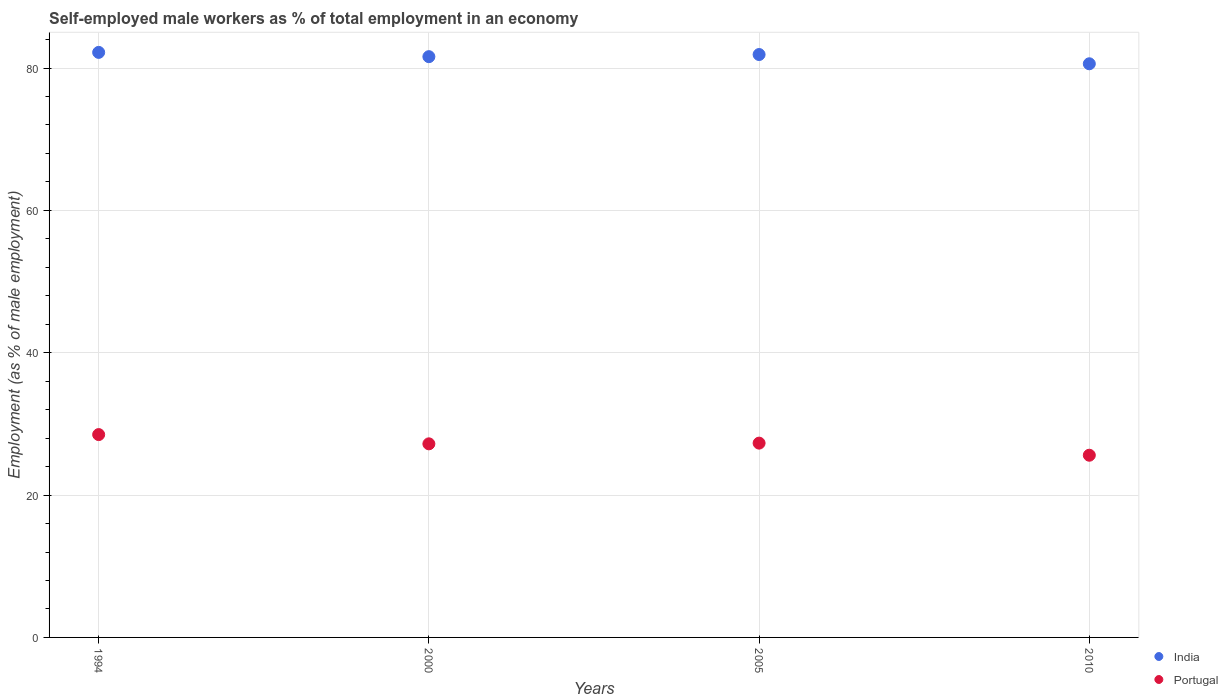What is the percentage of self-employed male workers in Portugal in 2005?
Keep it short and to the point. 27.3. Across all years, what is the maximum percentage of self-employed male workers in India?
Keep it short and to the point. 82.2. Across all years, what is the minimum percentage of self-employed male workers in India?
Ensure brevity in your answer.  80.6. In which year was the percentage of self-employed male workers in India maximum?
Provide a short and direct response. 1994. In which year was the percentage of self-employed male workers in Portugal minimum?
Your answer should be very brief. 2010. What is the total percentage of self-employed male workers in India in the graph?
Your answer should be very brief. 326.3. What is the difference between the percentage of self-employed male workers in Portugal in 2000 and that in 2010?
Provide a succinct answer. 1.6. What is the difference between the percentage of self-employed male workers in India in 1994 and the percentage of self-employed male workers in Portugal in 2010?
Your response must be concise. 56.6. What is the average percentage of self-employed male workers in Portugal per year?
Provide a succinct answer. 27.15. In the year 1994, what is the difference between the percentage of self-employed male workers in Portugal and percentage of self-employed male workers in India?
Offer a terse response. -53.7. In how many years, is the percentage of self-employed male workers in India greater than 52 %?
Offer a terse response. 4. What is the ratio of the percentage of self-employed male workers in India in 1994 to that in 2010?
Ensure brevity in your answer.  1.02. Is the percentage of self-employed male workers in India in 2000 less than that in 2010?
Provide a succinct answer. No. What is the difference between the highest and the second highest percentage of self-employed male workers in Portugal?
Provide a short and direct response. 1.2. What is the difference between the highest and the lowest percentage of self-employed male workers in India?
Your response must be concise. 1.6. Is the percentage of self-employed male workers in India strictly less than the percentage of self-employed male workers in Portugal over the years?
Offer a terse response. No. How many dotlines are there?
Your answer should be compact. 2. What is the difference between two consecutive major ticks on the Y-axis?
Give a very brief answer. 20. Does the graph contain any zero values?
Your answer should be compact. No. Does the graph contain grids?
Keep it short and to the point. Yes. Where does the legend appear in the graph?
Provide a short and direct response. Bottom right. What is the title of the graph?
Ensure brevity in your answer.  Self-employed male workers as % of total employment in an economy. What is the label or title of the X-axis?
Ensure brevity in your answer.  Years. What is the label or title of the Y-axis?
Make the answer very short. Employment (as % of male employment). What is the Employment (as % of male employment) of India in 1994?
Give a very brief answer. 82.2. What is the Employment (as % of male employment) of India in 2000?
Ensure brevity in your answer.  81.6. What is the Employment (as % of male employment) of Portugal in 2000?
Ensure brevity in your answer.  27.2. What is the Employment (as % of male employment) in India in 2005?
Provide a short and direct response. 81.9. What is the Employment (as % of male employment) of Portugal in 2005?
Provide a short and direct response. 27.3. What is the Employment (as % of male employment) of India in 2010?
Make the answer very short. 80.6. What is the Employment (as % of male employment) of Portugal in 2010?
Offer a terse response. 25.6. Across all years, what is the maximum Employment (as % of male employment) in India?
Make the answer very short. 82.2. Across all years, what is the maximum Employment (as % of male employment) of Portugal?
Your answer should be very brief. 28.5. Across all years, what is the minimum Employment (as % of male employment) of India?
Make the answer very short. 80.6. Across all years, what is the minimum Employment (as % of male employment) in Portugal?
Your answer should be very brief. 25.6. What is the total Employment (as % of male employment) of India in the graph?
Your answer should be compact. 326.3. What is the total Employment (as % of male employment) of Portugal in the graph?
Make the answer very short. 108.6. What is the difference between the Employment (as % of male employment) in India in 1994 and that in 2010?
Your answer should be very brief. 1.6. What is the difference between the Employment (as % of male employment) of India in 2000 and that in 2005?
Make the answer very short. -0.3. What is the difference between the Employment (as % of male employment) of Portugal in 2000 and that in 2005?
Provide a succinct answer. -0.1. What is the difference between the Employment (as % of male employment) of India in 2000 and that in 2010?
Ensure brevity in your answer.  1. What is the difference between the Employment (as % of male employment) in Portugal in 2000 and that in 2010?
Make the answer very short. 1.6. What is the difference between the Employment (as % of male employment) of India in 2005 and that in 2010?
Your answer should be very brief. 1.3. What is the difference between the Employment (as % of male employment) in India in 1994 and the Employment (as % of male employment) in Portugal in 2005?
Provide a short and direct response. 54.9. What is the difference between the Employment (as % of male employment) in India in 1994 and the Employment (as % of male employment) in Portugal in 2010?
Give a very brief answer. 56.6. What is the difference between the Employment (as % of male employment) of India in 2000 and the Employment (as % of male employment) of Portugal in 2005?
Offer a terse response. 54.3. What is the difference between the Employment (as % of male employment) of India in 2005 and the Employment (as % of male employment) of Portugal in 2010?
Provide a short and direct response. 56.3. What is the average Employment (as % of male employment) of India per year?
Provide a succinct answer. 81.58. What is the average Employment (as % of male employment) of Portugal per year?
Your answer should be compact. 27.15. In the year 1994, what is the difference between the Employment (as % of male employment) in India and Employment (as % of male employment) in Portugal?
Your answer should be compact. 53.7. In the year 2000, what is the difference between the Employment (as % of male employment) in India and Employment (as % of male employment) in Portugal?
Make the answer very short. 54.4. In the year 2005, what is the difference between the Employment (as % of male employment) of India and Employment (as % of male employment) of Portugal?
Offer a very short reply. 54.6. In the year 2010, what is the difference between the Employment (as % of male employment) of India and Employment (as % of male employment) of Portugal?
Make the answer very short. 55. What is the ratio of the Employment (as % of male employment) in India in 1994 to that in 2000?
Keep it short and to the point. 1.01. What is the ratio of the Employment (as % of male employment) of Portugal in 1994 to that in 2000?
Ensure brevity in your answer.  1.05. What is the ratio of the Employment (as % of male employment) in India in 1994 to that in 2005?
Keep it short and to the point. 1. What is the ratio of the Employment (as % of male employment) in Portugal in 1994 to that in 2005?
Keep it short and to the point. 1.04. What is the ratio of the Employment (as % of male employment) in India in 1994 to that in 2010?
Give a very brief answer. 1.02. What is the ratio of the Employment (as % of male employment) of Portugal in 1994 to that in 2010?
Your answer should be compact. 1.11. What is the ratio of the Employment (as % of male employment) in India in 2000 to that in 2005?
Your answer should be compact. 1. What is the ratio of the Employment (as % of male employment) of India in 2000 to that in 2010?
Provide a short and direct response. 1.01. What is the ratio of the Employment (as % of male employment) of Portugal in 2000 to that in 2010?
Make the answer very short. 1.06. What is the ratio of the Employment (as % of male employment) in India in 2005 to that in 2010?
Keep it short and to the point. 1.02. What is the ratio of the Employment (as % of male employment) in Portugal in 2005 to that in 2010?
Keep it short and to the point. 1.07. 